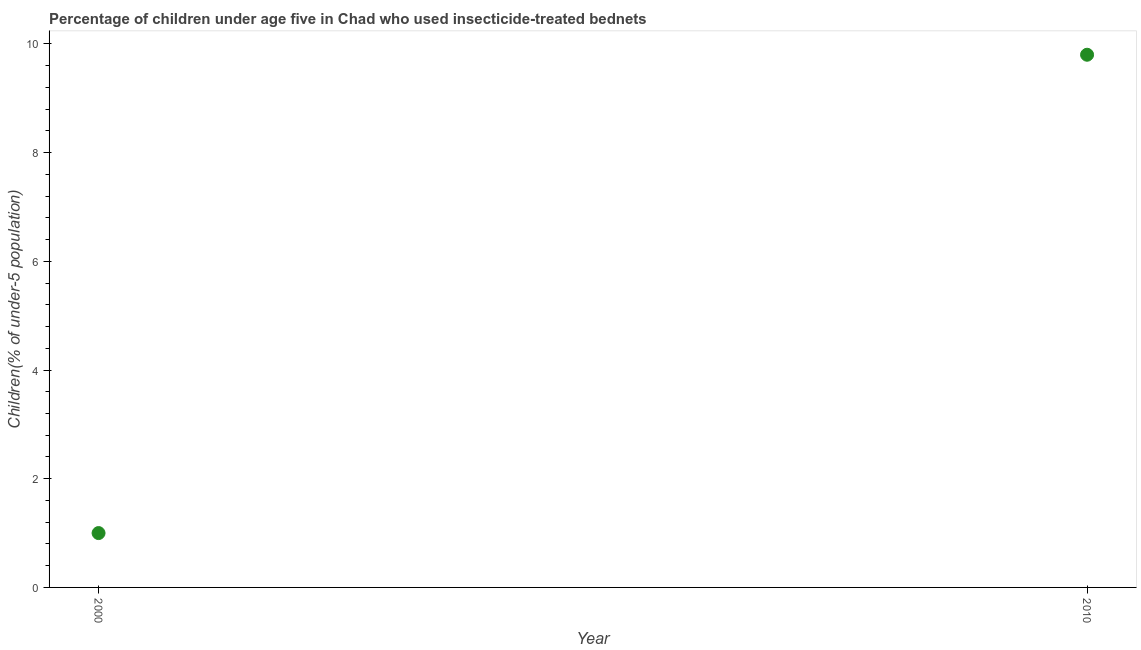Across all years, what is the maximum percentage of children who use of insecticide-treated bed nets?
Offer a very short reply. 9.8. What is the sum of the percentage of children who use of insecticide-treated bed nets?
Keep it short and to the point. 10.8. What is the difference between the percentage of children who use of insecticide-treated bed nets in 2000 and 2010?
Provide a succinct answer. -8.8. What is the average percentage of children who use of insecticide-treated bed nets per year?
Your response must be concise. 5.4. What is the median percentage of children who use of insecticide-treated bed nets?
Provide a succinct answer. 5.4. What is the ratio of the percentage of children who use of insecticide-treated bed nets in 2000 to that in 2010?
Your answer should be compact. 0.1. Does the percentage of children who use of insecticide-treated bed nets monotonically increase over the years?
Make the answer very short. Yes. How many years are there in the graph?
Your response must be concise. 2. What is the title of the graph?
Give a very brief answer. Percentage of children under age five in Chad who used insecticide-treated bednets. What is the label or title of the X-axis?
Provide a short and direct response. Year. What is the label or title of the Y-axis?
Offer a very short reply. Children(% of under-5 population). What is the Children(% of under-5 population) in 2010?
Ensure brevity in your answer.  9.8. What is the ratio of the Children(% of under-5 population) in 2000 to that in 2010?
Give a very brief answer. 0.1. 